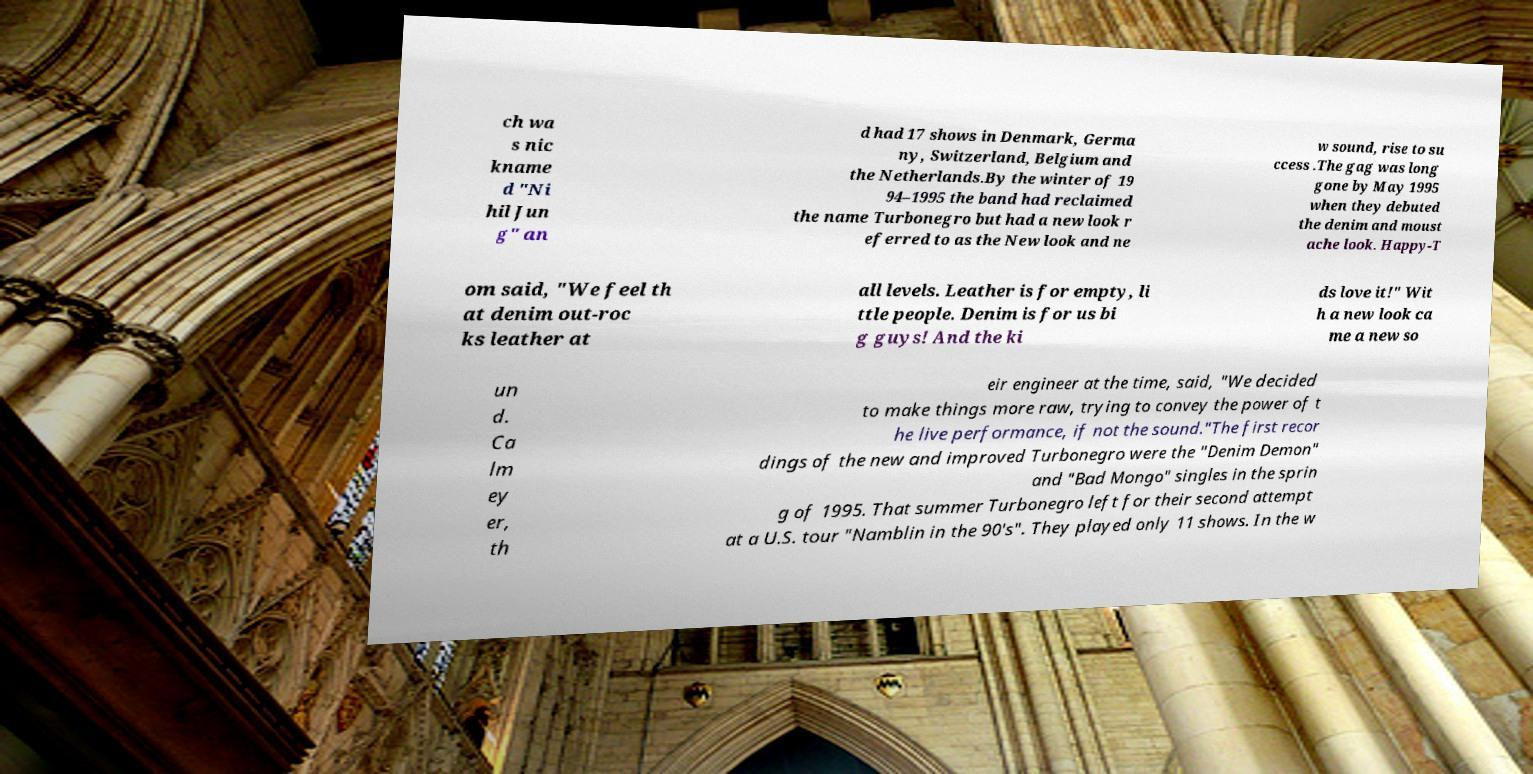There's text embedded in this image that I need extracted. Can you transcribe it verbatim? ch wa s nic kname d "Ni hil Jun g" an d had 17 shows in Denmark, Germa ny, Switzerland, Belgium and the Netherlands.By the winter of 19 94–1995 the band had reclaimed the name Turbonegro but had a new look r eferred to as the New look and ne w sound, rise to su ccess .The gag was long gone by May 1995 when they debuted the denim and moust ache look. Happy-T om said, "We feel th at denim out-roc ks leather at all levels. Leather is for empty, li ttle people. Denim is for us bi g guys! And the ki ds love it!" Wit h a new look ca me a new so un d. Ca lm ey er, th eir engineer at the time, said, "We decided to make things more raw, trying to convey the power of t he live performance, if not the sound."The first recor dings of the new and improved Turbonegro were the "Denim Demon" and "Bad Mongo" singles in the sprin g of 1995. That summer Turbonegro left for their second attempt at a U.S. tour "Namblin in the 90's". They played only 11 shows. In the w 